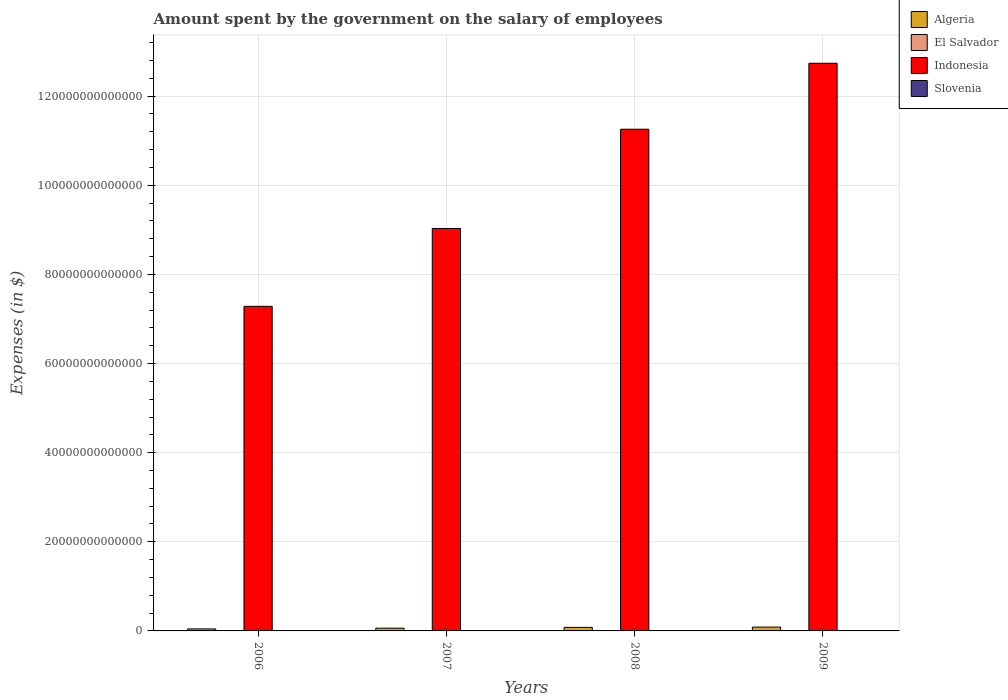How many groups of bars are there?
Give a very brief answer. 4. Are the number of bars on each tick of the X-axis equal?
Your answer should be compact. Yes. What is the label of the 1st group of bars from the left?
Provide a short and direct response. 2006. What is the amount spent on the salary of employees by the government in Algeria in 2008?
Keep it short and to the point. 7.97e+11. Across all years, what is the maximum amount spent on the salary of employees by the government in Slovenia?
Provide a succinct answer. 2.91e+09. Across all years, what is the minimum amount spent on the salary of employees by the government in El Salvador?
Offer a very short reply. 1.32e+09. What is the total amount spent on the salary of employees by the government in Slovenia in the graph?
Keep it short and to the point. 1.02e+1. What is the difference between the amount spent on the salary of employees by the government in Algeria in 2006 and that in 2008?
Give a very brief answer. -3.43e+11. What is the difference between the amount spent on the salary of employees by the government in Slovenia in 2008 and the amount spent on the salary of employees by the government in El Salvador in 2007?
Ensure brevity in your answer.  1.28e+09. What is the average amount spent on the salary of employees by the government in Indonesia per year?
Your response must be concise. 1.01e+14. In the year 2006, what is the difference between the amount spent on the salary of employees by the government in Algeria and amount spent on the salary of employees by the government in Slovenia?
Make the answer very short. 4.52e+11. What is the ratio of the amount spent on the salary of employees by the government in El Salvador in 2006 to that in 2008?
Offer a terse response. 0.87. What is the difference between the highest and the second highest amount spent on the salary of employees by the government in Algeria?
Give a very brief answer. 6.32e+1. What is the difference between the highest and the lowest amount spent on the salary of employees by the government in Indonesia?
Keep it short and to the point. 5.45e+13. What does the 4th bar from the left in 2006 represents?
Offer a terse response. Slovenia. What does the 1st bar from the right in 2006 represents?
Keep it short and to the point. Slovenia. How many bars are there?
Make the answer very short. 16. Are all the bars in the graph horizontal?
Give a very brief answer. No. What is the difference between two consecutive major ticks on the Y-axis?
Ensure brevity in your answer.  2.00e+13. Are the values on the major ticks of Y-axis written in scientific E-notation?
Offer a very short reply. No. Does the graph contain grids?
Ensure brevity in your answer.  Yes. Where does the legend appear in the graph?
Your answer should be compact. Top right. How many legend labels are there?
Your answer should be very brief. 4. How are the legend labels stacked?
Offer a very short reply. Vertical. What is the title of the graph?
Your answer should be very brief. Amount spent by the government on the salary of employees. What is the label or title of the X-axis?
Your answer should be very brief. Years. What is the label or title of the Y-axis?
Provide a short and direct response. Expenses (in $). What is the Expenses (in $) of Algeria in 2006?
Give a very brief answer. 4.54e+11. What is the Expenses (in $) in El Salvador in 2006?
Provide a succinct answer. 1.32e+09. What is the Expenses (in $) in Indonesia in 2006?
Provide a succinct answer. 7.28e+13. What is the Expenses (in $) in Slovenia in 2006?
Your answer should be compact. 2.24e+09. What is the Expenses (in $) of Algeria in 2007?
Keep it short and to the point. 6.20e+11. What is the Expenses (in $) in El Salvador in 2007?
Your answer should be compact. 1.39e+09. What is the Expenses (in $) in Indonesia in 2007?
Provide a short and direct response. 9.03e+13. What is the Expenses (in $) of Slovenia in 2007?
Provide a succinct answer. 2.35e+09. What is the Expenses (in $) in Algeria in 2008?
Offer a terse response. 7.97e+11. What is the Expenses (in $) in El Salvador in 2008?
Give a very brief answer. 1.51e+09. What is the Expenses (in $) of Indonesia in 2008?
Your response must be concise. 1.13e+14. What is the Expenses (in $) in Slovenia in 2008?
Offer a very short reply. 2.67e+09. What is the Expenses (in $) of Algeria in 2009?
Your answer should be compact. 8.61e+11. What is the Expenses (in $) of El Salvador in 2009?
Keep it short and to the point. 1.64e+09. What is the Expenses (in $) in Indonesia in 2009?
Offer a very short reply. 1.27e+14. What is the Expenses (in $) in Slovenia in 2009?
Provide a succinct answer. 2.91e+09. Across all years, what is the maximum Expenses (in $) of Algeria?
Your answer should be compact. 8.61e+11. Across all years, what is the maximum Expenses (in $) in El Salvador?
Your response must be concise. 1.64e+09. Across all years, what is the maximum Expenses (in $) of Indonesia?
Provide a short and direct response. 1.27e+14. Across all years, what is the maximum Expenses (in $) in Slovenia?
Provide a succinct answer. 2.91e+09. Across all years, what is the minimum Expenses (in $) in Algeria?
Offer a terse response. 4.54e+11. Across all years, what is the minimum Expenses (in $) in El Salvador?
Make the answer very short. 1.32e+09. Across all years, what is the minimum Expenses (in $) of Indonesia?
Provide a succinct answer. 7.28e+13. Across all years, what is the minimum Expenses (in $) of Slovenia?
Provide a succinct answer. 2.24e+09. What is the total Expenses (in $) in Algeria in the graph?
Provide a short and direct response. 2.73e+12. What is the total Expenses (in $) in El Salvador in the graph?
Offer a very short reply. 5.86e+09. What is the total Expenses (in $) in Indonesia in the graph?
Provide a succinct answer. 4.03e+14. What is the total Expenses (in $) of Slovenia in the graph?
Ensure brevity in your answer.  1.02e+1. What is the difference between the Expenses (in $) of Algeria in 2006 and that in 2007?
Ensure brevity in your answer.  -1.66e+11. What is the difference between the Expenses (in $) in El Salvador in 2006 and that in 2007?
Offer a terse response. -7.85e+07. What is the difference between the Expenses (in $) of Indonesia in 2006 and that in 2007?
Make the answer very short. -1.75e+13. What is the difference between the Expenses (in $) of Slovenia in 2006 and that in 2007?
Your response must be concise. -1.04e+08. What is the difference between the Expenses (in $) of Algeria in 2006 and that in 2008?
Offer a very short reply. -3.43e+11. What is the difference between the Expenses (in $) in El Salvador in 2006 and that in 2008?
Your response must be concise. -1.95e+08. What is the difference between the Expenses (in $) in Indonesia in 2006 and that in 2008?
Offer a terse response. -3.97e+13. What is the difference between the Expenses (in $) in Slovenia in 2006 and that in 2008?
Offer a terse response. -4.27e+08. What is the difference between the Expenses (in $) in Algeria in 2006 and that in 2009?
Offer a terse response. -4.06e+11. What is the difference between the Expenses (in $) in El Salvador in 2006 and that in 2009?
Offer a terse response. -3.22e+08. What is the difference between the Expenses (in $) of Indonesia in 2006 and that in 2009?
Provide a short and direct response. -5.45e+13. What is the difference between the Expenses (in $) of Slovenia in 2006 and that in 2009?
Provide a succinct answer. -6.64e+08. What is the difference between the Expenses (in $) of Algeria in 2007 and that in 2008?
Give a very brief answer. -1.77e+11. What is the difference between the Expenses (in $) of El Salvador in 2007 and that in 2008?
Provide a succinct answer. -1.17e+08. What is the difference between the Expenses (in $) in Indonesia in 2007 and that in 2008?
Your answer should be very brief. -2.23e+13. What is the difference between the Expenses (in $) in Slovenia in 2007 and that in 2008?
Offer a terse response. -3.23e+08. What is the difference between the Expenses (in $) of Algeria in 2007 and that in 2009?
Your answer should be very brief. -2.40e+11. What is the difference between the Expenses (in $) in El Salvador in 2007 and that in 2009?
Your answer should be compact. -2.44e+08. What is the difference between the Expenses (in $) in Indonesia in 2007 and that in 2009?
Offer a very short reply. -3.71e+13. What is the difference between the Expenses (in $) of Slovenia in 2007 and that in 2009?
Ensure brevity in your answer.  -5.60e+08. What is the difference between the Expenses (in $) of Algeria in 2008 and that in 2009?
Give a very brief answer. -6.32e+1. What is the difference between the Expenses (in $) in El Salvador in 2008 and that in 2009?
Your answer should be compact. -1.27e+08. What is the difference between the Expenses (in $) in Indonesia in 2008 and that in 2009?
Your answer should be very brief. -1.48e+13. What is the difference between the Expenses (in $) in Slovenia in 2008 and that in 2009?
Your answer should be very brief. -2.36e+08. What is the difference between the Expenses (in $) in Algeria in 2006 and the Expenses (in $) in El Salvador in 2007?
Make the answer very short. 4.53e+11. What is the difference between the Expenses (in $) in Algeria in 2006 and the Expenses (in $) in Indonesia in 2007?
Provide a succinct answer. -8.99e+13. What is the difference between the Expenses (in $) of Algeria in 2006 and the Expenses (in $) of Slovenia in 2007?
Make the answer very short. 4.52e+11. What is the difference between the Expenses (in $) of El Salvador in 2006 and the Expenses (in $) of Indonesia in 2007?
Offer a terse response. -9.03e+13. What is the difference between the Expenses (in $) in El Salvador in 2006 and the Expenses (in $) in Slovenia in 2007?
Ensure brevity in your answer.  -1.03e+09. What is the difference between the Expenses (in $) of Indonesia in 2006 and the Expenses (in $) of Slovenia in 2007?
Offer a very short reply. 7.28e+13. What is the difference between the Expenses (in $) in Algeria in 2006 and the Expenses (in $) in El Salvador in 2008?
Provide a succinct answer. 4.53e+11. What is the difference between the Expenses (in $) of Algeria in 2006 and the Expenses (in $) of Indonesia in 2008?
Your answer should be compact. -1.12e+14. What is the difference between the Expenses (in $) in Algeria in 2006 and the Expenses (in $) in Slovenia in 2008?
Make the answer very short. 4.51e+11. What is the difference between the Expenses (in $) of El Salvador in 2006 and the Expenses (in $) of Indonesia in 2008?
Offer a very short reply. -1.13e+14. What is the difference between the Expenses (in $) in El Salvador in 2006 and the Expenses (in $) in Slovenia in 2008?
Provide a short and direct response. -1.35e+09. What is the difference between the Expenses (in $) of Indonesia in 2006 and the Expenses (in $) of Slovenia in 2008?
Ensure brevity in your answer.  7.28e+13. What is the difference between the Expenses (in $) of Algeria in 2006 and the Expenses (in $) of El Salvador in 2009?
Provide a succinct answer. 4.52e+11. What is the difference between the Expenses (in $) in Algeria in 2006 and the Expenses (in $) in Indonesia in 2009?
Your answer should be very brief. -1.27e+14. What is the difference between the Expenses (in $) of Algeria in 2006 and the Expenses (in $) of Slovenia in 2009?
Keep it short and to the point. 4.51e+11. What is the difference between the Expenses (in $) in El Salvador in 2006 and the Expenses (in $) in Indonesia in 2009?
Offer a terse response. -1.27e+14. What is the difference between the Expenses (in $) in El Salvador in 2006 and the Expenses (in $) in Slovenia in 2009?
Provide a short and direct response. -1.59e+09. What is the difference between the Expenses (in $) of Indonesia in 2006 and the Expenses (in $) of Slovenia in 2009?
Your answer should be very brief. 7.28e+13. What is the difference between the Expenses (in $) in Algeria in 2007 and the Expenses (in $) in El Salvador in 2008?
Make the answer very short. 6.19e+11. What is the difference between the Expenses (in $) of Algeria in 2007 and the Expenses (in $) of Indonesia in 2008?
Offer a very short reply. -1.12e+14. What is the difference between the Expenses (in $) in Algeria in 2007 and the Expenses (in $) in Slovenia in 2008?
Ensure brevity in your answer.  6.18e+11. What is the difference between the Expenses (in $) in El Salvador in 2007 and the Expenses (in $) in Indonesia in 2008?
Your answer should be compact. -1.13e+14. What is the difference between the Expenses (in $) of El Salvador in 2007 and the Expenses (in $) of Slovenia in 2008?
Your answer should be very brief. -1.28e+09. What is the difference between the Expenses (in $) in Indonesia in 2007 and the Expenses (in $) in Slovenia in 2008?
Offer a very short reply. 9.03e+13. What is the difference between the Expenses (in $) of Algeria in 2007 and the Expenses (in $) of El Salvador in 2009?
Provide a succinct answer. 6.19e+11. What is the difference between the Expenses (in $) of Algeria in 2007 and the Expenses (in $) of Indonesia in 2009?
Provide a short and direct response. -1.27e+14. What is the difference between the Expenses (in $) of Algeria in 2007 and the Expenses (in $) of Slovenia in 2009?
Your answer should be very brief. 6.17e+11. What is the difference between the Expenses (in $) in El Salvador in 2007 and the Expenses (in $) in Indonesia in 2009?
Keep it short and to the point. -1.27e+14. What is the difference between the Expenses (in $) in El Salvador in 2007 and the Expenses (in $) in Slovenia in 2009?
Your response must be concise. -1.51e+09. What is the difference between the Expenses (in $) of Indonesia in 2007 and the Expenses (in $) of Slovenia in 2009?
Provide a short and direct response. 9.03e+13. What is the difference between the Expenses (in $) of Algeria in 2008 and the Expenses (in $) of El Salvador in 2009?
Make the answer very short. 7.96e+11. What is the difference between the Expenses (in $) in Algeria in 2008 and the Expenses (in $) in Indonesia in 2009?
Your answer should be very brief. -1.27e+14. What is the difference between the Expenses (in $) of Algeria in 2008 and the Expenses (in $) of Slovenia in 2009?
Make the answer very short. 7.94e+11. What is the difference between the Expenses (in $) in El Salvador in 2008 and the Expenses (in $) in Indonesia in 2009?
Offer a very short reply. -1.27e+14. What is the difference between the Expenses (in $) in El Salvador in 2008 and the Expenses (in $) in Slovenia in 2009?
Provide a short and direct response. -1.40e+09. What is the difference between the Expenses (in $) of Indonesia in 2008 and the Expenses (in $) of Slovenia in 2009?
Provide a succinct answer. 1.13e+14. What is the average Expenses (in $) in Algeria per year?
Your answer should be compact. 6.83e+11. What is the average Expenses (in $) in El Salvador per year?
Give a very brief answer. 1.47e+09. What is the average Expenses (in $) of Indonesia per year?
Provide a short and direct response. 1.01e+14. What is the average Expenses (in $) in Slovenia per year?
Provide a succinct answer. 2.54e+09. In the year 2006, what is the difference between the Expenses (in $) in Algeria and Expenses (in $) in El Salvador?
Provide a succinct answer. 4.53e+11. In the year 2006, what is the difference between the Expenses (in $) of Algeria and Expenses (in $) of Indonesia?
Keep it short and to the point. -7.24e+13. In the year 2006, what is the difference between the Expenses (in $) in Algeria and Expenses (in $) in Slovenia?
Give a very brief answer. 4.52e+11. In the year 2006, what is the difference between the Expenses (in $) in El Salvador and Expenses (in $) in Indonesia?
Provide a succinct answer. -7.28e+13. In the year 2006, what is the difference between the Expenses (in $) in El Salvador and Expenses (in $) in Slovenia?
Provide a succinct answer. -9.27e+08. In the year 2006, what is the difference between the Expenses (in $) of Indonesia and Expenses (in $) of Slovenia?
Make the answer very short. 7.28e+13. In the year 2007, what is the difference between the Expenses (in $) in Algeria and Expenses (in $) in El Salvador?
Offer a terse response. 6.19e+11. In the year 2007, what is the difference between the Expenses (in $) in Algeria and Expenses (in $) in Indonesia?
Your answer should be compact. -8.97e+13. In the year 2007, what is the difference between the Expenses (in $) of Algeria and Expenses (in $) of Slovenia?
Make the answer very short. 6.18e+11. In the year 2007, what is the difference between the Expenses (in $) in El Salvador and Expenses (in $) in Indonesia?
Give a very brief answer. -9.03e+13. In the year 2007, what is the difference between the Expenses (in $) in El Salvador and Expenses (in $) in Slovenia?
Give a very brief answer. -9.53e+08. In the year 2007, what is the difference between the Expenses (in $) of Indonesia and Expenses (in $) of Slovenia?
Provide a succinct answer. 9.03e+13. In the year 2008, what is the difference between the Expenses (in $) of Algeria and Expenses (in $) of El Salvador?
Your answer should be compact. 7.96e+11. In the year 2008, what is the difference between the Expenses (in $) of Algeria and Expenses (in $) of Indonesia?
Offer a very short reply. -1.12e+14. In the year 2008, what is the difference between the Expenses (in $) of Algeria and Expenses (in $) of Slovenia?
Offer a terse response. 7.95e+11. In the year 2008, what is the difference between the Expenses (in $) in El Salvador and Expenses (in $) in Indonesia?
Offer a very short reply. -1.13e+14. In the year 2008, what is the difference between the Expenses (in $) in El Salvador and Expenses (in $) in Slovenia?
Give a very brief answer. -1.16e+09. In the year 2008, what is the difference between the Expenses (in $) in Indonesia and Expenses (in $) in Slovenia?
Provide a succinct answer. 1.13e+14. In the year 2009, what is the difference between the Expenses (in $) in Algeria and Expenses (in $) in El Salvador?
Your response must be concise. 8.59e+11. In the year 2009, what is the difference between the Expenses (in $) of Algeria and Expenses (in $) of Indonesia?
Give a very brief answer. -1.27e+14. In the year 2009, what is the difference between the Expenses (in $) in Algeria and Expenses (in $) in Slovenia?
Make the answer very short. 8.58e+11. In the year 2009, what is the difference between the Expenses (in $) of El Salvador and Expenses (in $) of Indonesia?
Make the answer very short. -1.27e+14. In the year 2009, what is the difference between the Expenses (in $) of El Salvador and Expenses (in $) of Slovenia?
Your answer should be compact. -1.27e+09. In the year 2009, what is the difference between the Expenses (in $) in Indonesia and Expenses (in $) in Slovenia?
Ensure brevity in your answer.  1.27e+14. What is the ratio of the Expenses (in $) of Algeria in 2006 to that in 2007?
Provide a short and direct response. 0.73. What is the ratio of the Expenses (in $) in El Salvador in 2006 to that in 2007?
Offer a terse response. 0.94. What is the ratio of the Expenses (in $) in Indonesia in 2006 to that in 2007?
Your response must be concise. 0.81. What is the ratio of the Expenses (in $) in Slovenia in 2006 to that in 2007?
Give a very brief answer. 0.96. What is the ratio of the Expenses (in $) of Algeria in 2006 to that in 2008?
Your answer should be compact. 0.57. What is the ratio of the Expenses (in $) of El Salvador in 2006 to that in 2008?
Your answer should be compact. 0.87. What is the ratio of the Expenses (in $) of Indonesia in 2006 to that in 2008?
Your answer should be compact. 0.65. What is the ratio of the Expenses (in $) of Slovenia in 2006 to that in 2008?
Provide a succinct answer. 0.84. What is the ratio of the Expenses (in $) in Algeria in 2006 to that in 2009?
Ensure brevity in your answer.  0.53. What is the ratio of the Expenses (in $) of El Salvador in 2006 to that in 2009?
Your response must be concise. 0.8. What is the ratio of the Expenses (in $) in Indonesia in 2006 to that in 2009?
Keep it short and to the point. 0.57. What is the ratio of the Expenses (in $) in Slovenia in 2006 to that in 2009?
Provide a succinct answer. 0.77. What is the ratio of the Expenses (in $) in Algeria in 2007 to that in 2008?
Make the answer very short. 0.78. What is the ratio of the Expenses (in $) in El Salvador in 2007 to that in 2008?
Provide a succinct answer. 0.92. What is the ratio of the Expenses (in $) in Indonesia in 2007 to that in 2008?
Your answer should be very brief. 0.8. What is the ratio of the Expenses (in $) of Slovenia in 2007 to that in 2008?
Provide a short and direct response. 0.88. What is the ratio of the Expenses (in $) of Algeria in 2007 to that in 2009?
Offer a terse response. 0.72. What is the ratio of the Expenses (in $) of El Salvador in 2007 to that in 2009?
Your answer should be very brief. 0.85. What is the ratio of the Expenses (in $) of Indonesia in 2007 to that in 2009?
Provide a succinct answer. 0.71. What is the ratio of the Expenses (in $) in Slovenia in 2007 to that in 2009?
Give a very brief answer. 0.81. What is the ratio of the Expenses (in $) in Algeria in 2008 to that in 2009?
Your response must be concise. 0.93. What is the ratio of the Expenses (in $) of El Salvador in 2008 to that in 2009?
Your response must be concise. 0.92. What is the ratio of the Expenses (in $) of Indonesia in 2008 to that in 2009?
Your answer should be compact. 0.88. What is the ratio of the Expenses (in $) of Slovenia in 2008 to that in 2009?
Keep it short and to the point. 0.92. What is the difference between the highest and the second highest Expenses (in $) in Algeria?
Your answer should be very brief. 6.32e+1. What is the difference between the highest and the second highest Expenses (in $) of El Salvador?
Provide a succinct answer. 1.27e+08. What is the difference between the highest and the second highest Expenses (in $) of Indonesia?
Your response must be concise. 1.48e+13. What is the difference between the highest and the second highest Expenses (in $) of Slovenia?
Offer a very short reply. 2.36e+08. What is the difference between the highest and the lowest Expenses (in $) in Algeria?
Give a very brief answer. 4.06e+11. What is the difference between the highest and the lowest Expenses (in $) of El Salvador?
Offer a very short reply. 3.22e+08. What is the difference between the highest and the lowest Expenses (in $) in Indonesia?
Provide a succinct answer. 5.45e+13. What is the difference between the highest and the lowest Expenses (in $) in Slovenia?
Ensure brevity in your answer.  6.64e+08. 